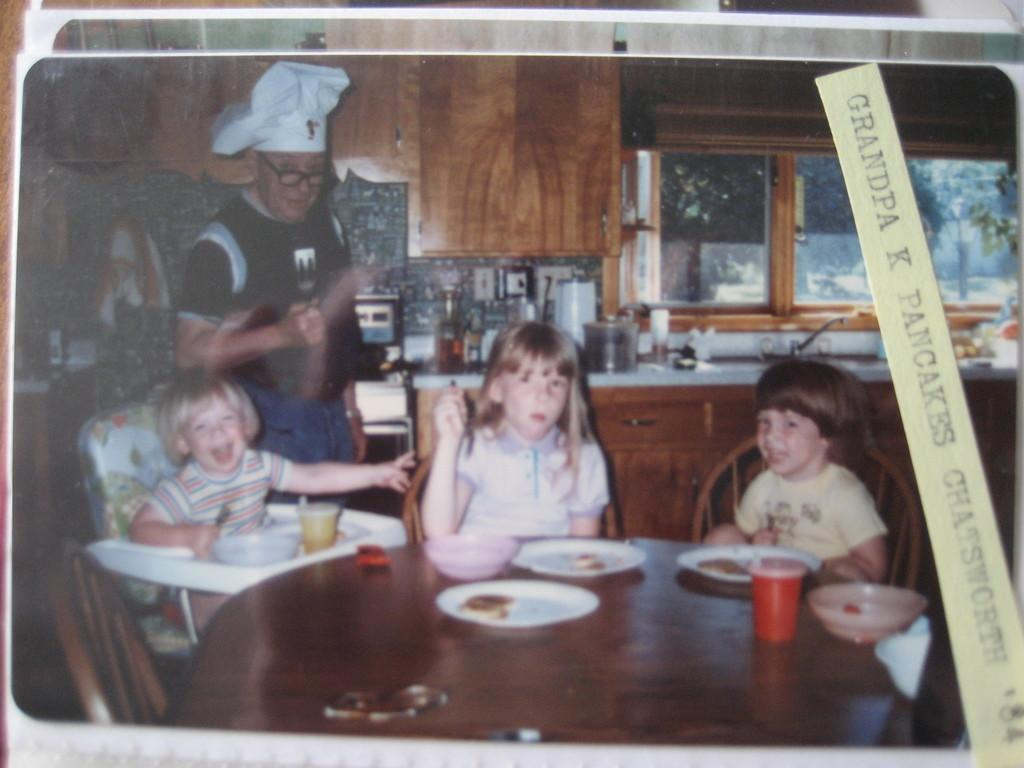What type of furniture is present in the image? There are tables and chairs in the image. Are there any people in the image? Yes, there are people in the image. What can be seen through the window in the image? The presence of a window suggests that there might be a view of the outdoors, but the specific view cannot be determined from the facts provided. What is located near the sink in the image? The facts do not specify any objects or features near the sink. What items are on the table in the image? There are plates, glasses, and food items on the table in the image. What type of clock is hanging on the wall in the image? There is no clock present in the image. What is the tin used for in the image? There is no tin present in the image. 